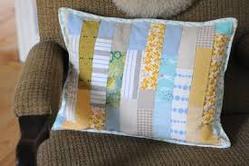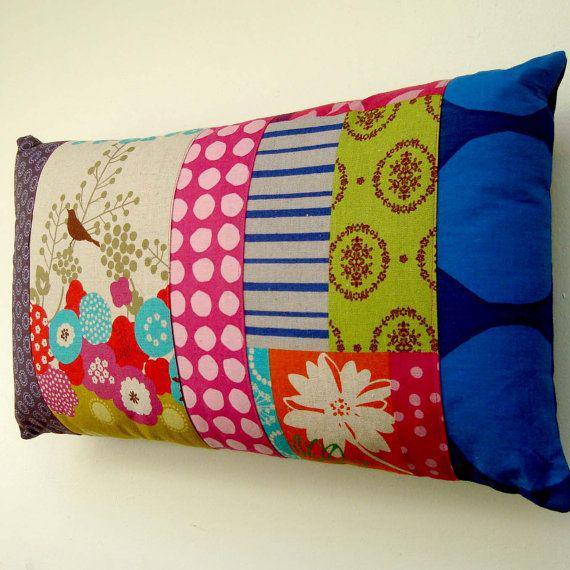The first image is the image on the left, the second image is the image on the right. Analyze the images presented: Is the assertion "One pillow has a vertical stripe pattern." valid? Answer yes or no. Yes. The first image is the image on the left, the second image is the image on the right. Evaluate the accuracy of this statement regarding the images: "The left and right image contains the same number of quilted piece of fabric.". Is it true? Answer yes or no. Yes. 